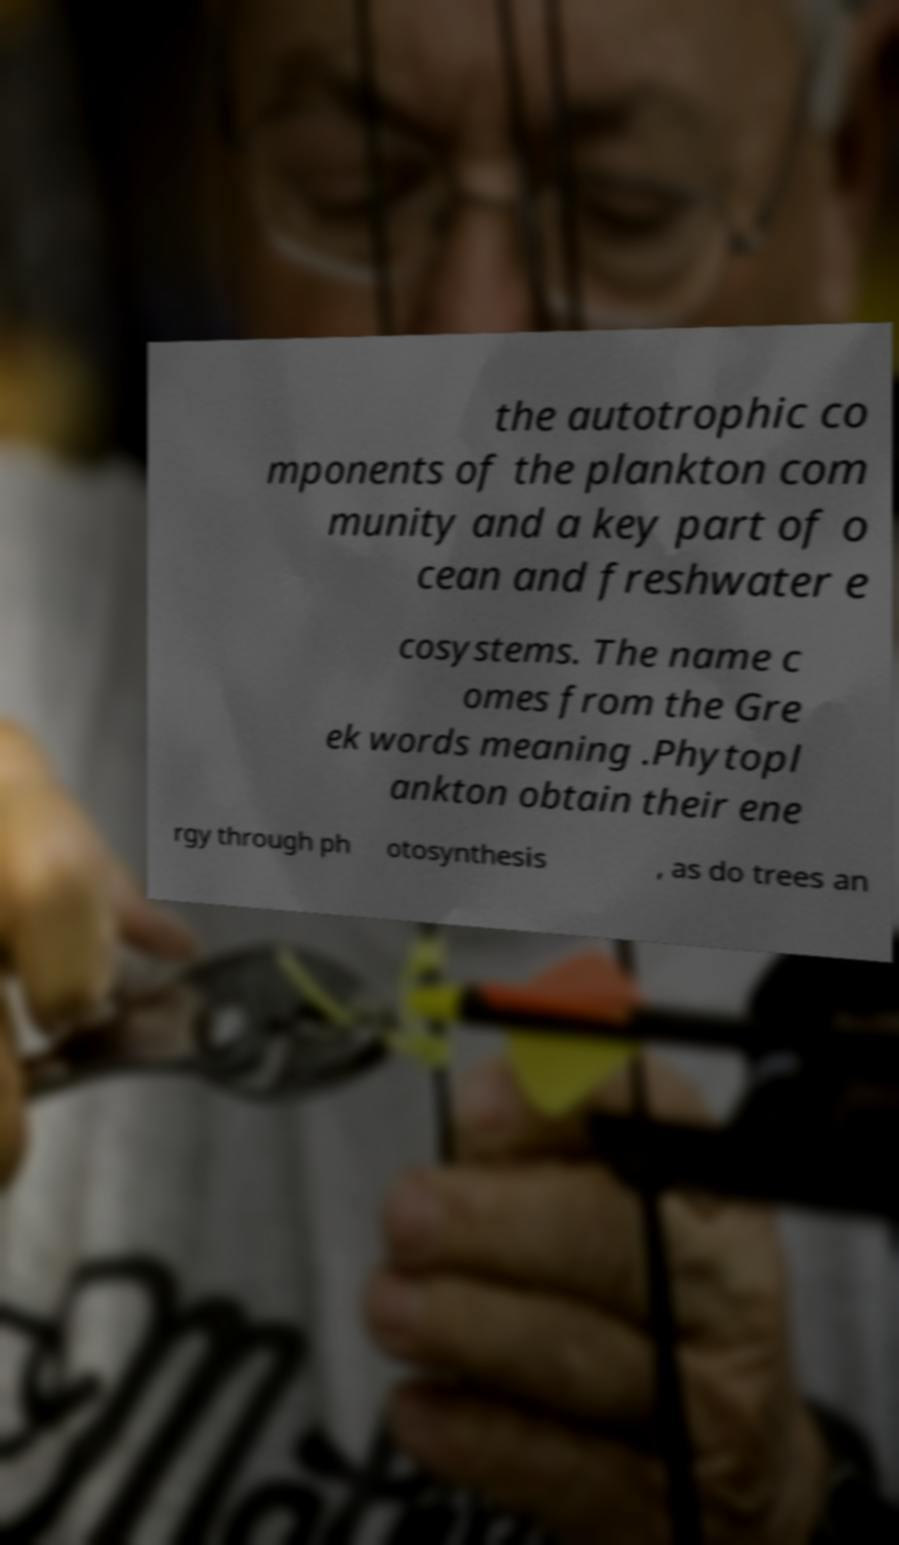What messages or text are displayed in this image? I need them in a readable, typed format. the autotrophic co mponents of the plankton com munity and a key part of o cean and freshwater e cosystems. The name c omes from the Gre ek words meaning .Phytopl ankton obtain their ene rgy through ph otosynthesis , as do trees an 